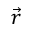<formula> <loc_0><loc_0><loc_500><loc_500>\vec { r }</formula> 